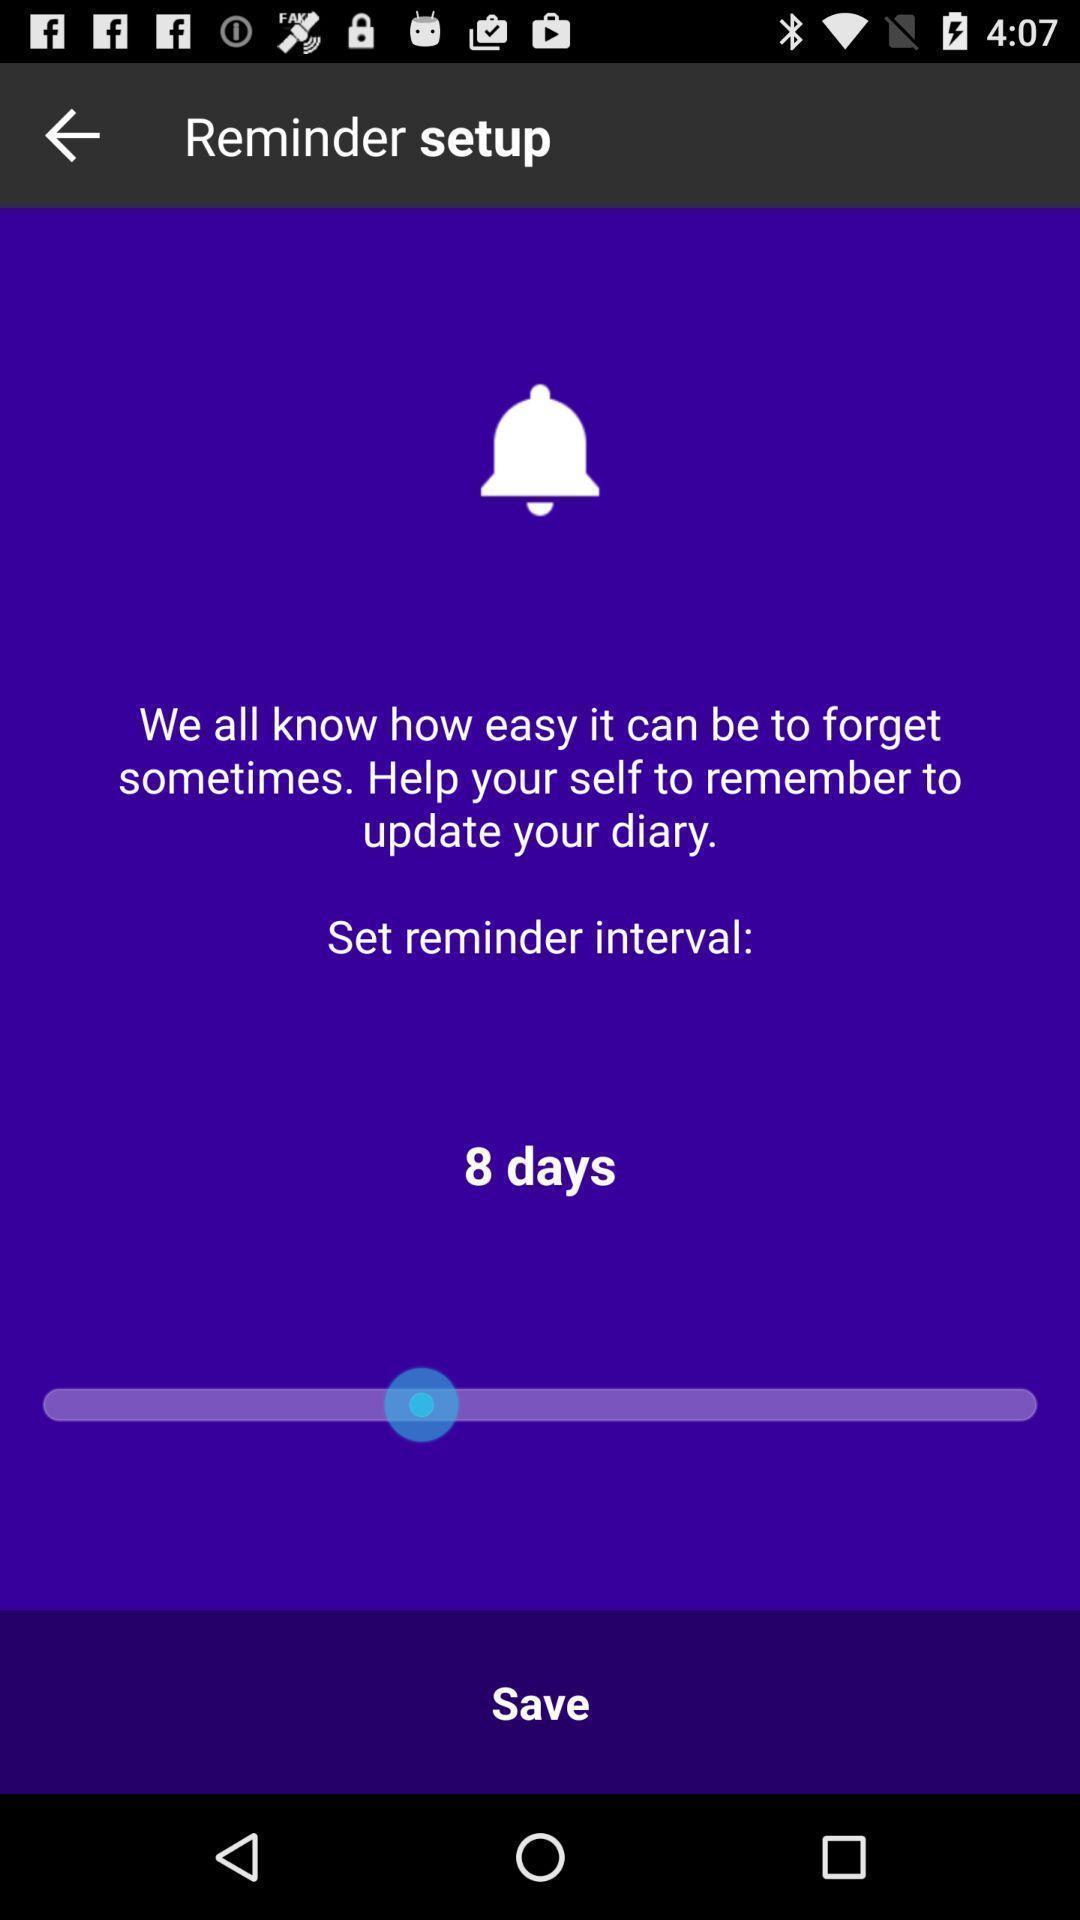Describe the content in this image. Page displaying the remainder setup. 